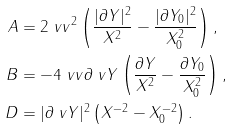<formula> <loc_0><loc_0><loc_500><loc_500>A & = 2 \ v v ^ { 2 } \left ( \frac { | \partial Y | ^ { 2 } } { X ^ { 2 } } - \frac { | \partial Y _ { 0 } | ^ { 2 } } { X _ { 0 } ^ { 2 } } \right ) , \\ B & = - 4 \ v v \partial \ v Y \left ( \frac { \partial Y } { X ^ { 2 } } - \frac { \partial Y _ { 0 } } { X _ { 0 } ^ { 2 } } \right ) , \\ D & = | \partial \ v Y | ^ { 2 } \left ( X ^ { - 2 } - X _ { 0 } ^ { - 2 } \right ) .</formula> 